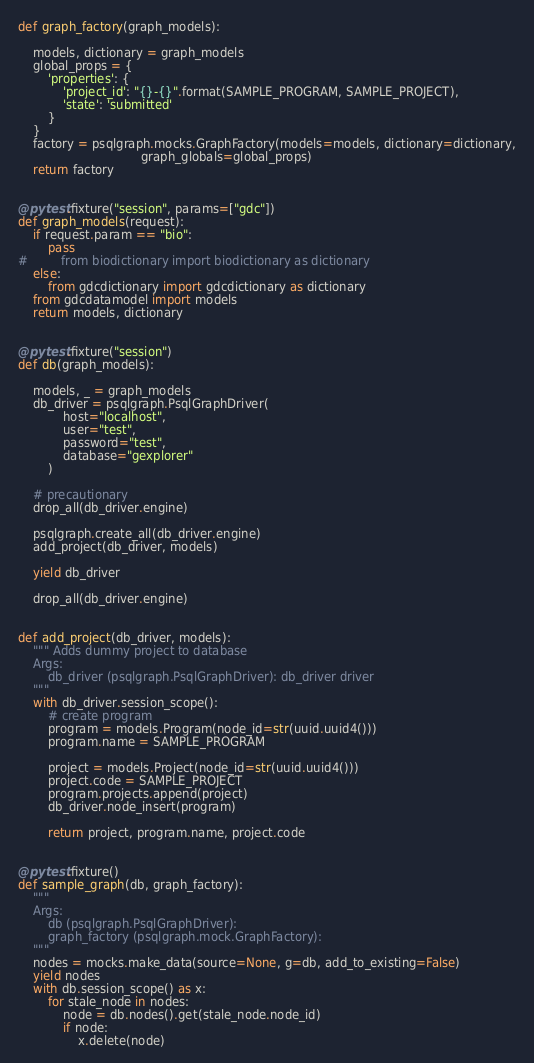Convert code to text. <code><loc_0><loc_0><loc_500><loc_500><_Python_>def graph_factory(graph_models):
    
    models, dictionary = graph_models
    global_props = {
        'properties': {
            'project_id': "{}-{}".format(SAMPLE_PROGRAM, SAMPLE_PROJECT),
            'state': 'submitted'
        }
    }
    factory = psqlgraph.mocks.GraphFactory(models=models, dictionary=dictionary,
                                 graph_globals=global_props)
    return factory


@pytest.fixture("session", params=["gdc"])
def graph_models(request):
    if request.param == "bio":
        pass
#         from biodictionary import biodictionary as dictionary
    else:
        from gdcdictionary import gdcdictionary as dictionary
    from gdcdatamodel import models
    return models, dictionary


@pytest.fixture("session")
def db(graph_models):
    
    models, _ = graph_models
    db_driver = psqlgraph.PsqlGraphDriver(
            host="localhost",
            user="test",
            password="test",
            database="gexplorer"
        )
    
    # precautionary
    drop_all(db_driver.engine)
    
    psqlgraph.create_all(db_driver.engine)
    add_project(db_driver, models)
    
    yield db_driver
    
    drop_all(db_driver.engine)


def add_project(db_driver, models):
    """ Adds dummy project to database
    Args:
        db_driver (psqlgraph.PsqlGraphDriver): db_driver driver
    """
    with db_driver.session_scope():
        # create program
        program = models.Program(node_id=str(uuid.uuid4()))
        program.name = SAMPLE_PROGRAM

        project = models.Project(node_id=str(uuid.uuid4()))
        project.code = SAMPLE_PROJECT
        program.projects.append(project)
        db_driver.node_insert(program)

        return project, program.name, project.code


@pytest.fixture()
def sample_graph(db, graph_factory):
    """
    Args:
        db (psqlgraph.PsqlGraphDriver):
        graph_factory (psqlgraph.mock.GraphFactory):
    """
    nodes = mocks.make_data(source=None, g=db, add_to_existing=False)
    yield nodes
    with db.session_scope() as x:
        for stale_node in nodes:
            node = db.nodes().get(stale_node.node_id)
            if node:
                x.delete(node)
</code> 